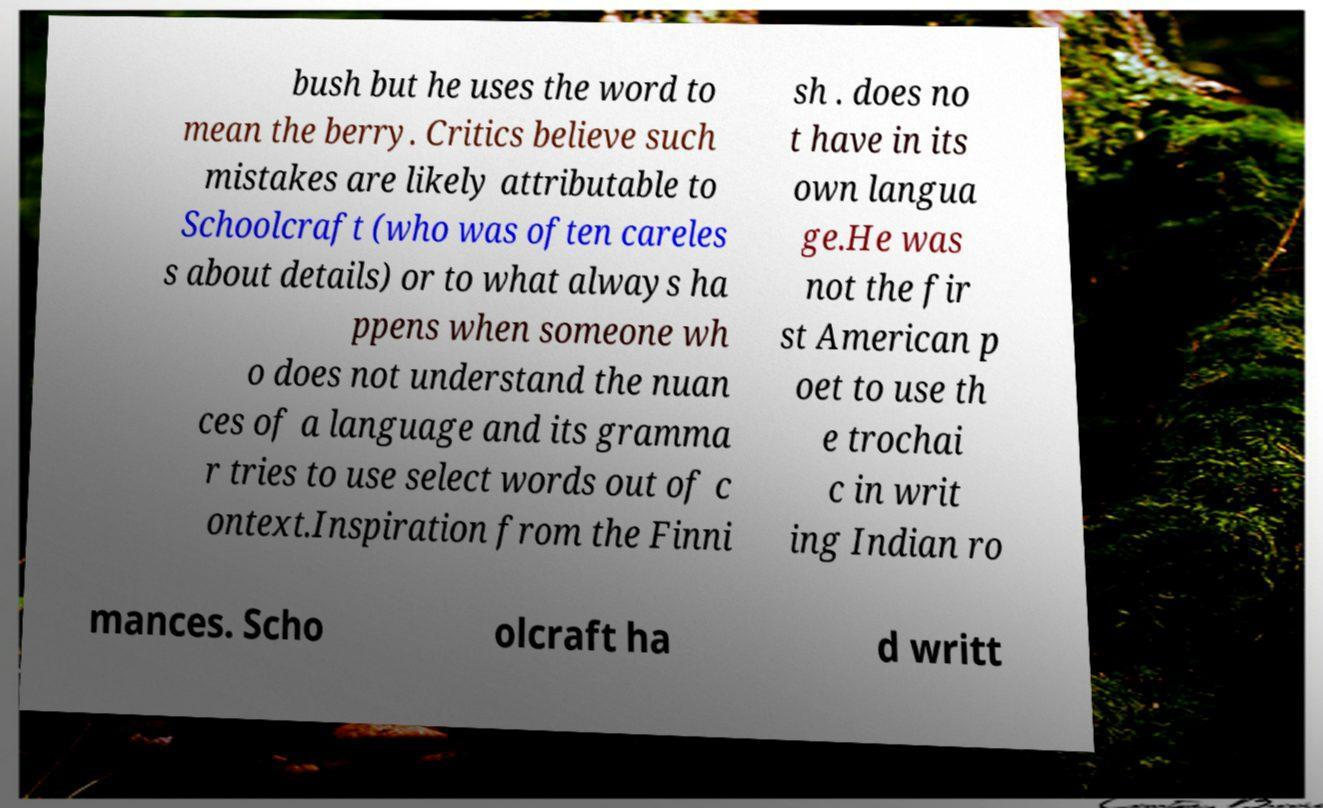Could you extract and type out the text from this image? bush but he uses the word to mean the berry. Critics believe such mistakes are likely attributable to Schoolcraft (who was often careles s about details) or to what always ha ppens when someone wh o does not understand the nuan ces of a language and its gramma r tries to use select words out of c ontext.Inspiration from the Finni sh . does no t have in its own langua ge.He was not the fir st American p oet to use th e trochai c in writ ing Indian ro mances. Scho olcraft ha d writt 